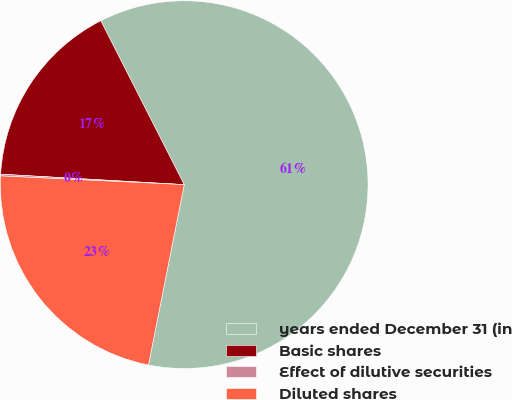Convert chart to OTSL. <chart><loc_0><loc_0><loc_500><loc_500><pie_chart><fcel>years ended December 31 (in<fcel>Basic shares<fcel>Effect of dilutive securities<fcel>Diluted shares<nl><fcel>60.61%<fcel>16.6%<fcel>0.15%<fcel>22.64%<nl></chart> 